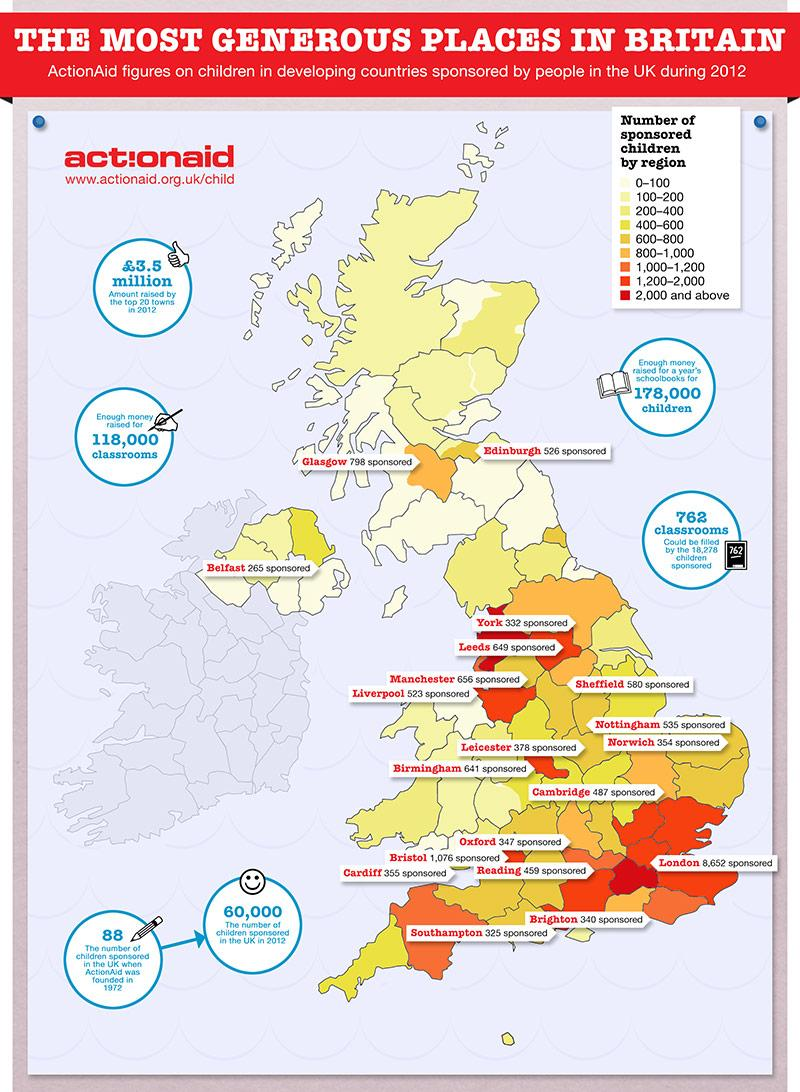Point out several critical features in this image. ActionAid sponsored a total of 88 children in 1972, and in 2012, the organization sponsored 60,000 children. According to the data, the region with the highest number of sponsored children is London. Among the regions of Oxford, Bristol, Cardiff, and Reading, Bristol has the highest number of sponsored children. It is Bristol that has the second highest number of sponsored children. In 2012, Oxford had a lower number of children sponsored compared to Cambridge. 